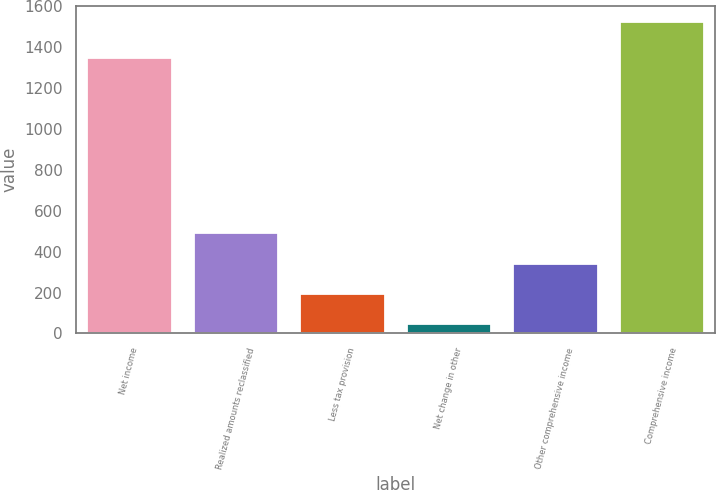<chart> <loc_0><loc_0><loc_500><loc_500><bar_chart><fcel>Net income<fcel>Realized amounts reclassified<fcel>Less tax provision<fcel>Net change in other<fcel>Other comprehensive income<fcel>Comprehensive income<nl><fcel>1350<fcel>493.6<fcel>199.2<fcel>52<fcel>346.4<fcel>1524<nl></chart> 